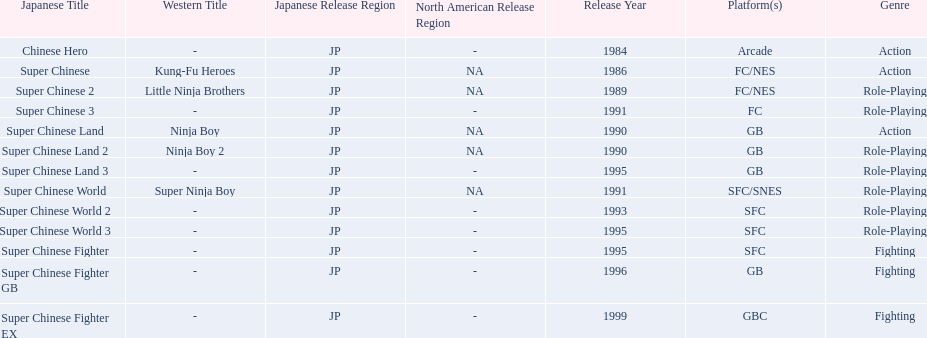What japanese titles were released in the north american (na) region? Super Chinese, Super Chinese 2, Super Chinese Land, Super Chinese Land 2, Super Chinese World. Of those, which one was released most recently? Super Chinese World. 